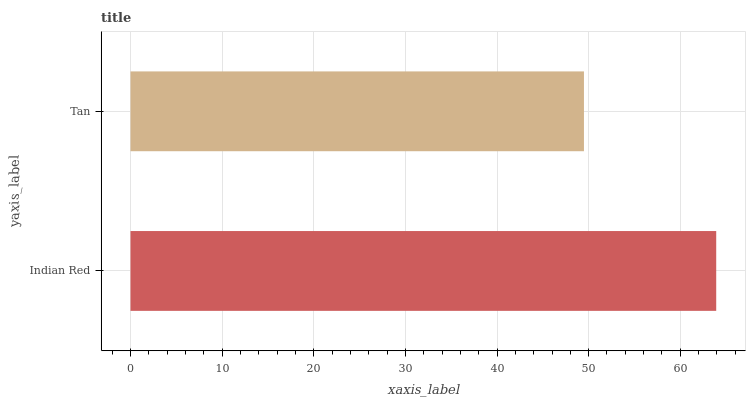Is Tan the minimum?
Answer yes or no. Yes. Is Indian Red the maximum?
Answer yes or no. Yes. Is Tan the maximum?
Answer yes or no. No. Is Indian Red greater than Tan?
Answer yes or no. Yes. Is Tan less than Indian Red?
Answer yes or no. Yes. Is Tan greater than Indian Red?
Answer yes or no. No. Is Indian Red less than Tan?
Answer yes or no. No. Is Indian Red the high median?
Answer yes or no. Yes. Is Tan the low median?
Answer yes or no. Yes. Is Tan the high median?
Answer yes or no. No. Is Indian Red the low median?
Answer yes or no. No. 